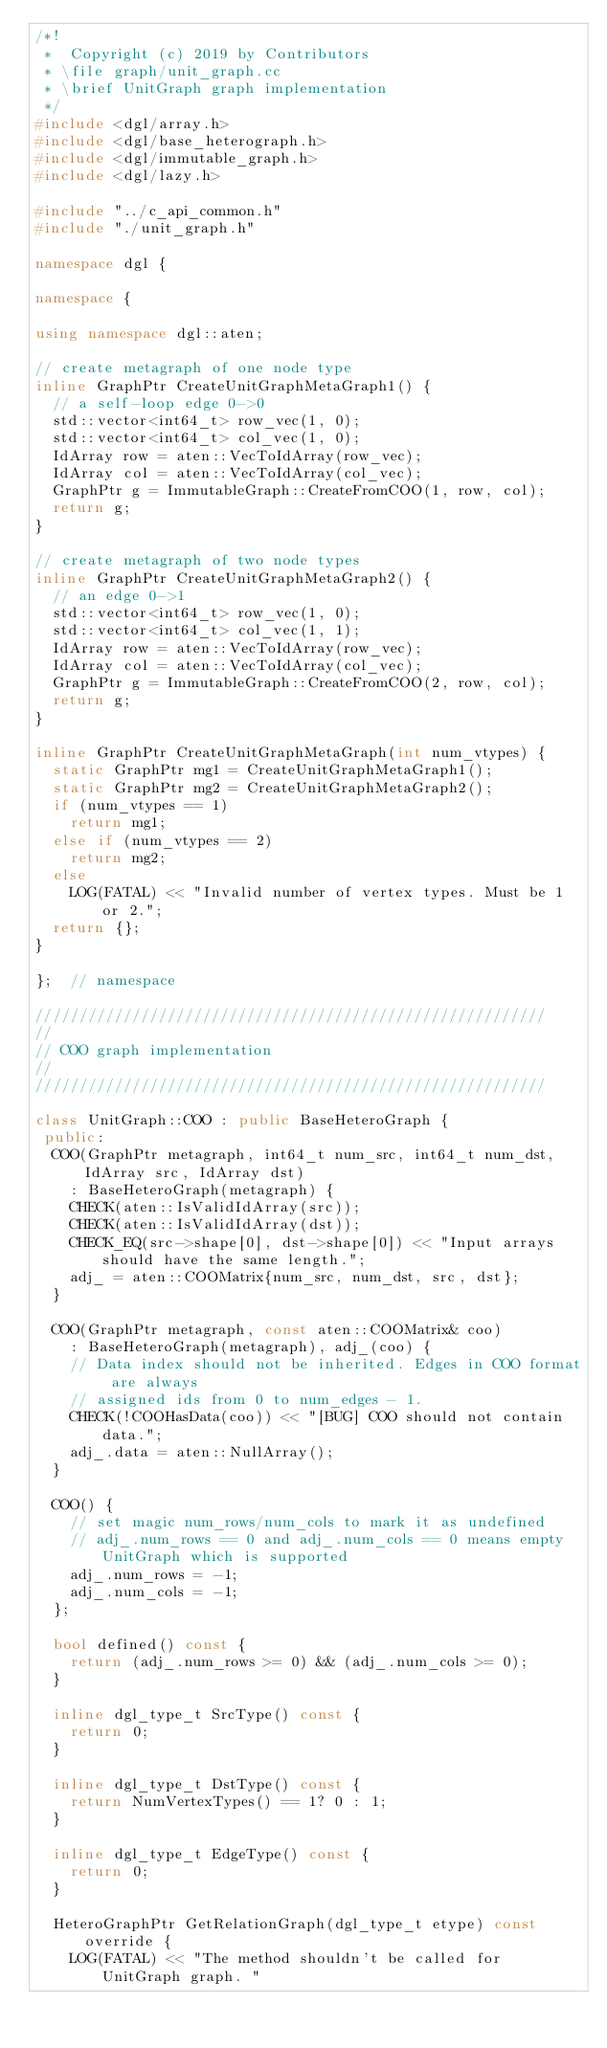<code> <loc_0><loc_0><loc_500><loc_500><_C++_>/*!
 *  Copyright (c) 2019 by Contributors
 * \file graph/unit_graph.cc
 * \brief UnitGraph graph implementation
 */
#include <dgl/array.h>
#include <dgl/base_heterograph.h>
#include <dgl/immutable_graph.h>
#include <dgl/lazy.h>

#include "../c_api_common.h"
#include "./unit_graph.h"

namespace dgl {

namespace {

using namespace dgl::aten;

// create metagraph of one node type
inline GraphPtr CreateUnitGraphMetaGraph1() {
  // a self-loop edge 0->0
  std::vector<int64_t> row_vec(1, 0);
  std::vector<int64_t> col_vec(1, 0);
  IdArray row = aten::VecToIdArray(row_vec);
  IdArray col = aten::VecToIdArray(col_vec);
  GraphPtr g = ImmutableGraph::CreateFromCOO(1, row, col);
  return g;
}

// create metagraph of two node types
inline GraphPtr CreateUnitGraphMetaGraph2() {
  // an edge 0->1
  std::vector<int64_t> row_vec(1, 0);
  std::vector<int64_t> col_vec(1, 1);
  IdArray row = aten::VecToIdArray(row_vec);
  IdArray col = aten::VecToIdArray(col_vec);
  GraphPtr g = ImmutableGraph::CreateFromCOO(2, row, col);
  return g;
}

inline GraphPtr CreateUnitGraphMetaGraph(int num_vtypes) {
  static GraphPtr mg1 = CreateUnitGraphMetaGraph1();
  static GraphPtr mg2 = CreateUnitGraphMetaGraph2();
  if (num_vtypes == 1)
    return mg1;
  else if (num_vtypes == 2)
    return mg2;
  else
    LOG(FATAL) << "Invalid number of vertex types. Must be 1 or 2.";
  return {};
}

};  // namespace

//////////////////////////////////////////////////////////
//
// COO graph implementation
//
//////////////////////////////////////////////////////////

class UnitGraph::COO : public BaseHeteroGraph {
 public:
  COO(GraphPtr metagraph, int64_t num_src, int64_t num_dst, IdArray src, IdArray dst)
    : BaseHeteroGraph(metagraph) {
    CHECK(aten::IsValidIdArray(src));
    CHECK(aten::IsValidIdArray(dst));
    CHECK_EQ(src->shape[0], dst->shape[0]) << "Input arrays should have the same length.";
    adj_ = aten::COOMatrix{num_src, num_dst, src, dst};
  }

  COO(GraphPtr metagraph, const aten::COOMatrix& coo)
    : BaseHeteroGraph(metagraph), adj_(coo) {
    // Data index should not be inherited. Edges in COO format are always
    // assigned ids from 0 to num_edges - 1.
    CHECK(!COOHasData(coo)) << "[BUG] COO should not contain data.";
    adj_.data = aten::NullArray();
  }

  COO() {
    // set magic num_rows/num_cols to mark it as undefined
    // adj_.num_rows == 0 and adj_.num_cols == 0 means empty UnitGraph which is supported
    adj_.num_rows = -1;
    adj_.num_cols = -1;
  };

  bool defined() const {
    return (adj_.num_rows >= 0) && (adj_.num_cols >= 0);
  }

  inline dgl_type_t SrcType() const {
    return 0;
  }

  inline dgl_type_t DstType() const {
    return NumVertexTypes() == 1? 0 : 1;
  }

  inline dgl_type_t EdgeType() const {
    return 0;
  }

  HeteroGraphPtr GetRelationGraph(dgl_type_t etype) const override {
    LOG(FATAL) << "The method shouldn't be called for UnitGraph graph. "</code> 